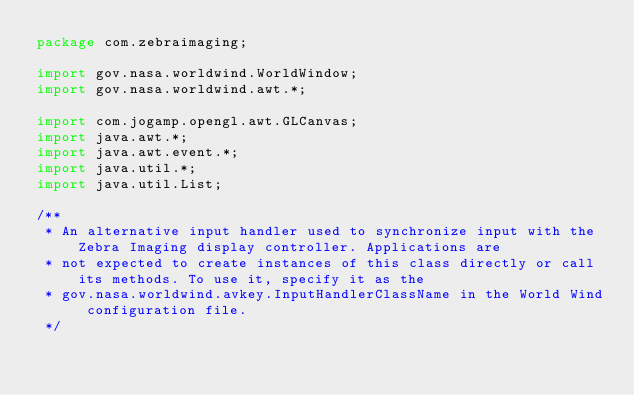Convert code to text. <code><loc_0><loc_0><loc_500><loc_500><_Java_>package com.zebraimaging;

import gov.nasa.worldwind.WorldWindow;
import gov.nasa.worldwind.awt.*;

import com.jogamp.opengl.awt.GLCanvas;
import java.awt.*;
import java.awt.event.*;
import java.util.*;
import java.util.List;

/**
 * An alternative input handler used to synchronize input with the Zebra Imaging display controller. Applications are
 * not expected to create instances of this class directly or call its methods. To use it, specify it as the
 * gov.nasa.worldwind.avkey.InputHandlerClassName in the World Wind configuration file.
 */</code> 